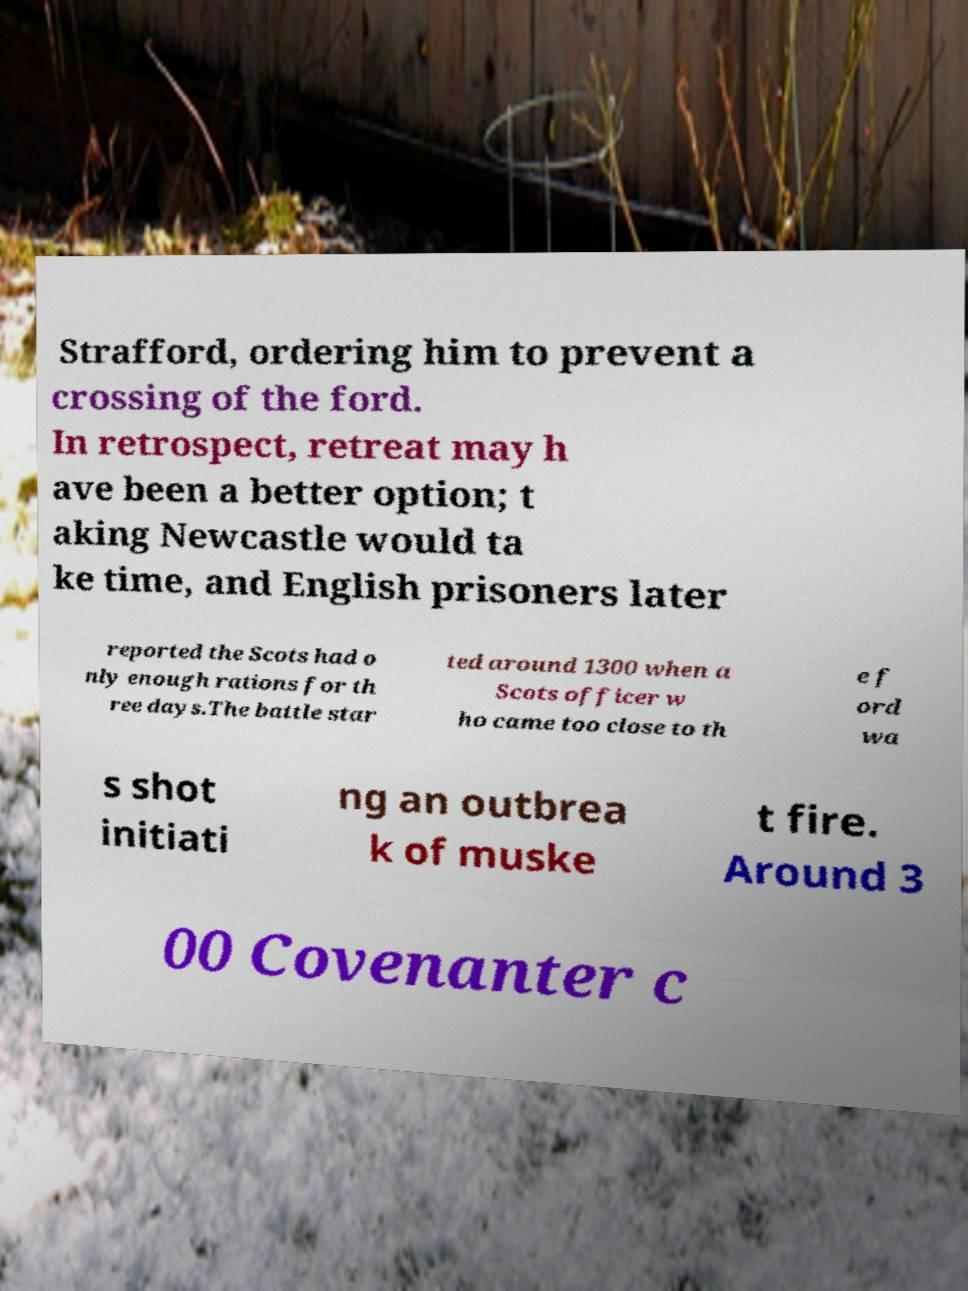I need the written content from this picture converted into text. Can you do that? Strafford, ordering him to prevent a crossing of the ford. In retrospect, retreat may h ave been a better option; t aking Newcastle would ta ke time, and English prisoners later reported the Scots had o nly enough rations for th ree days.The battle star ted around 1300 when a Scots officer w ho came too close to th e f ord wa s shot initiati ng an outbrea k of muske t fire. Around 3 00 Covenanter c 